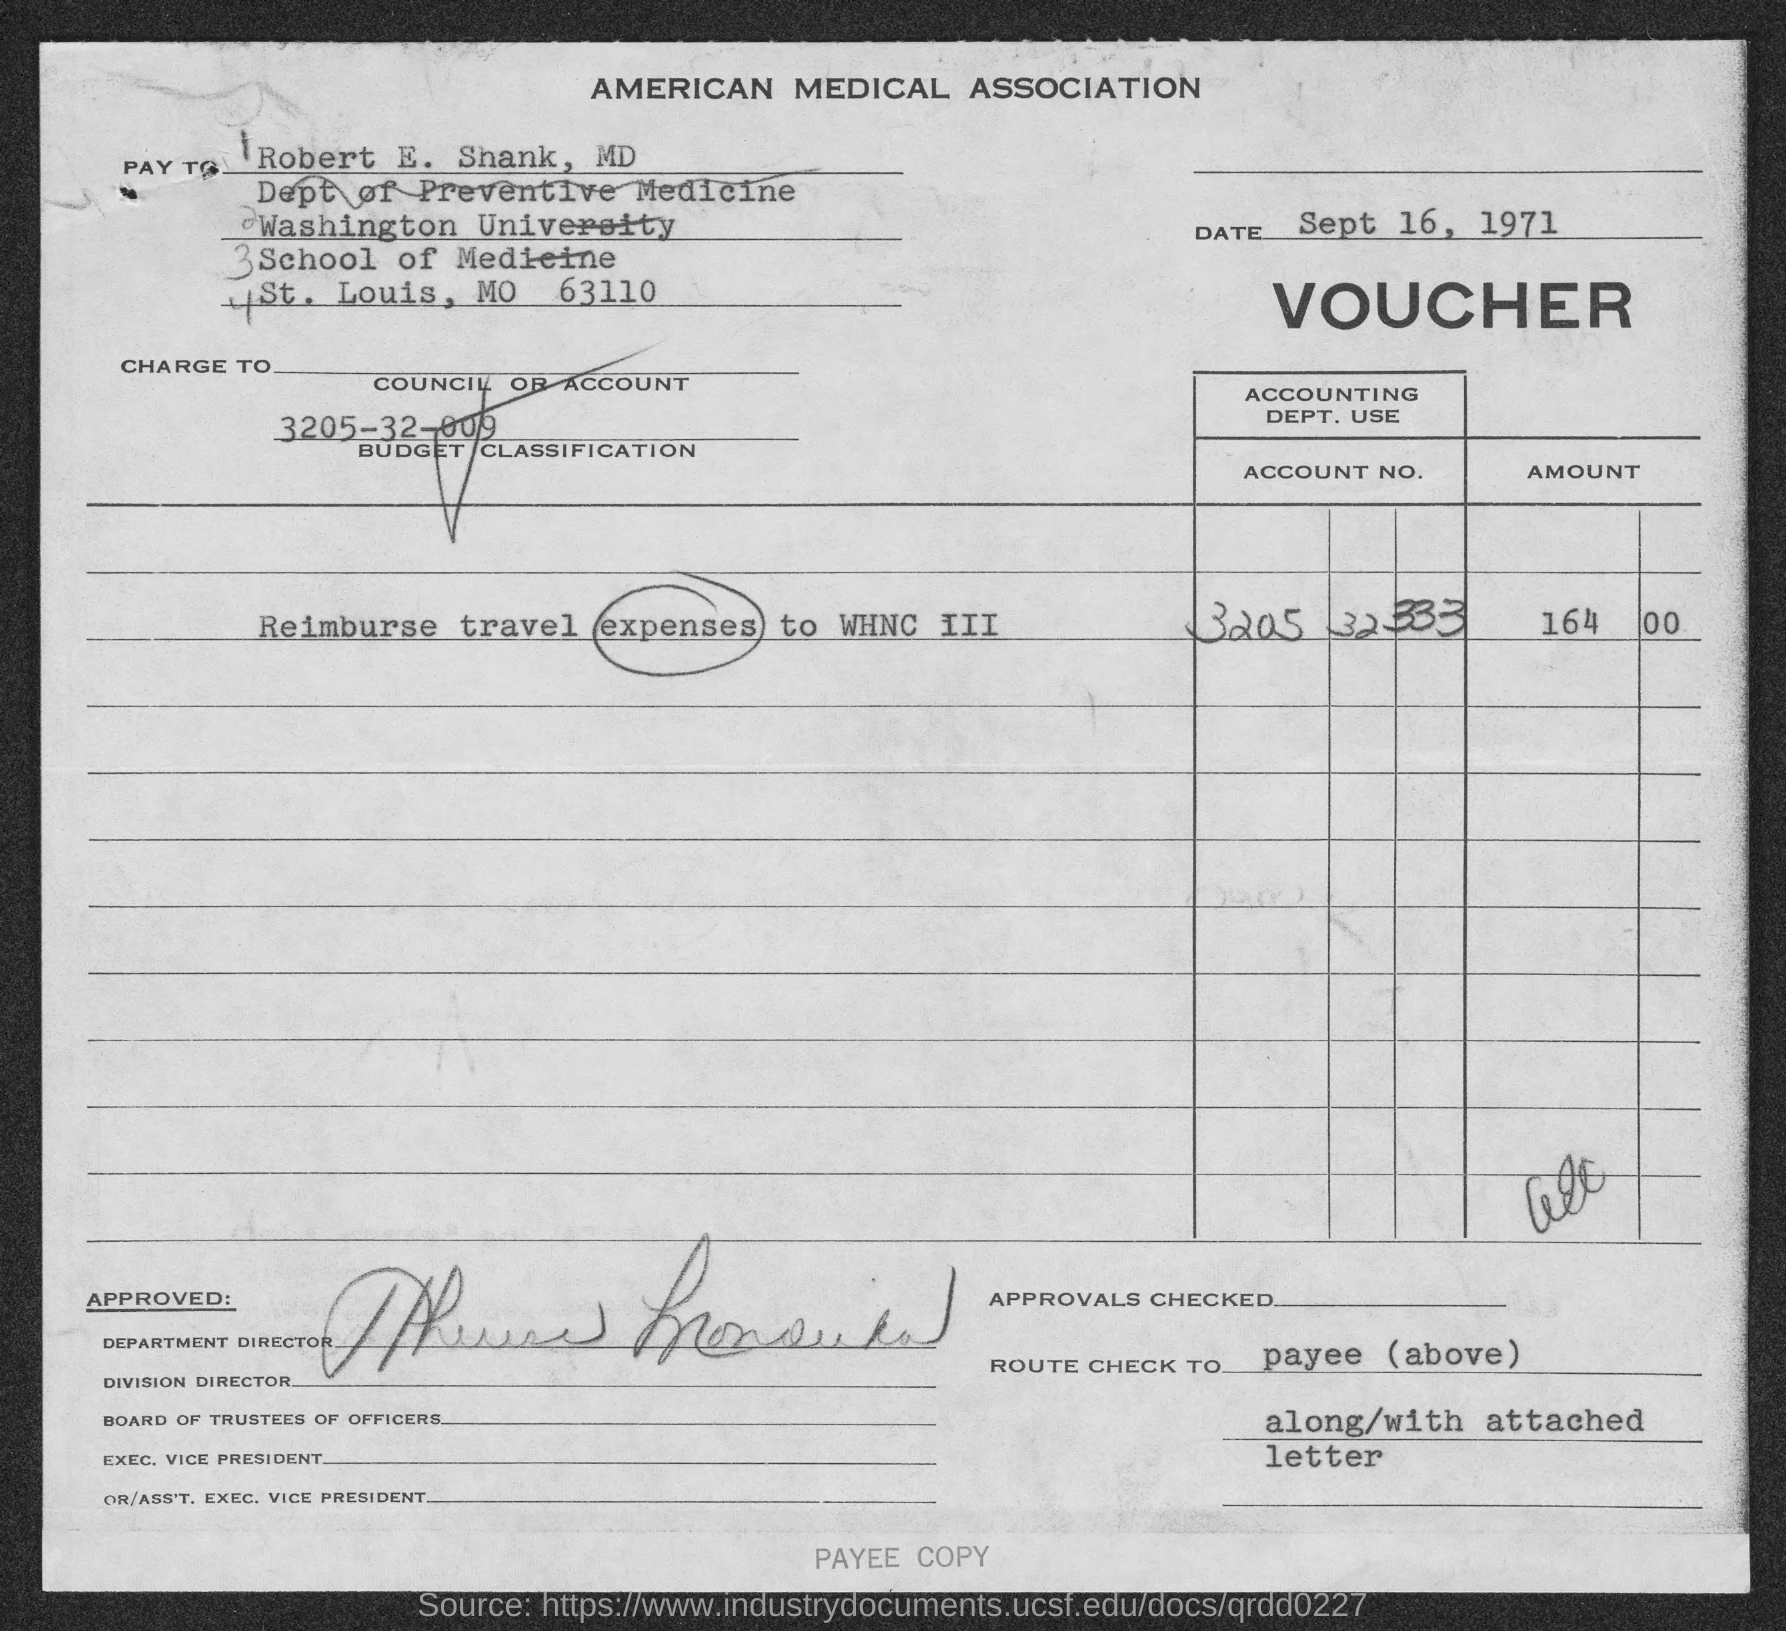When is the memorandum dated on ?
Provide a succinct answer. Sept 16, 1971. 